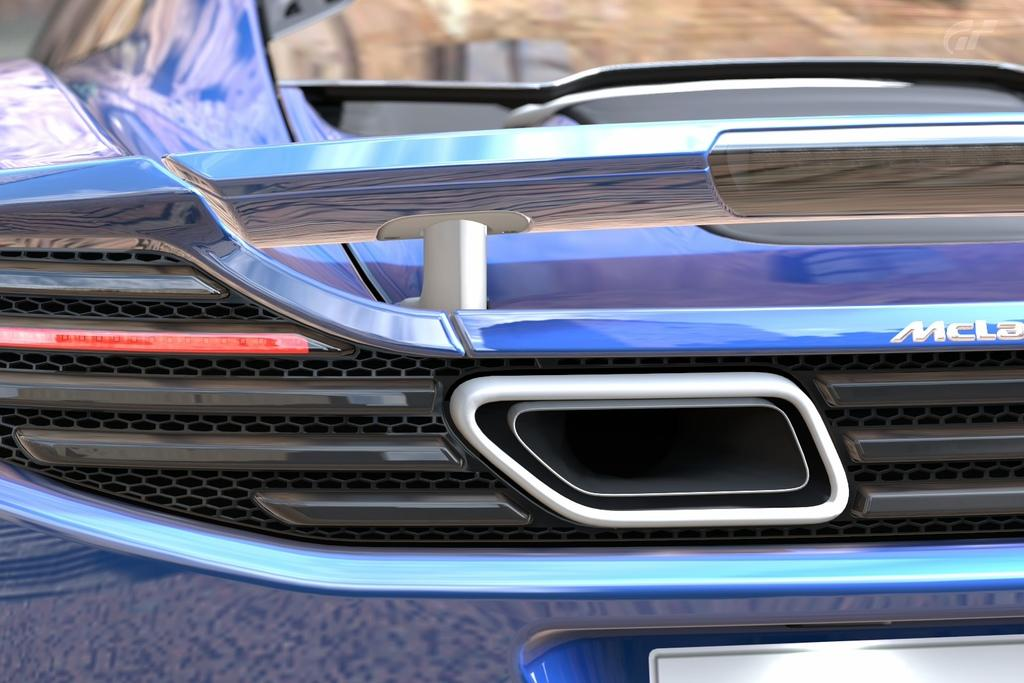What is the main subject of the image? There is a car in the image. What type of quilt is draped over the car in the image? There is no quilt present in the image; it only features a car. 